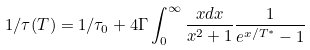<formula> <loc_0><loc_0><loc_500><loc_500>1 / \tau ( T ) = 1 / \tau _ { 0 } + 4 \Gamma \int _ { 0 } ^ { \infty } \frac { x d x } { x ^ { 2 } + 1 } \frac { 1 } { e ^ { x / T ^ { * } } - 1 }</formula> 